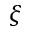<formula> <loc_0><loc_0><loc_500><loc_500>\xi</formula> 